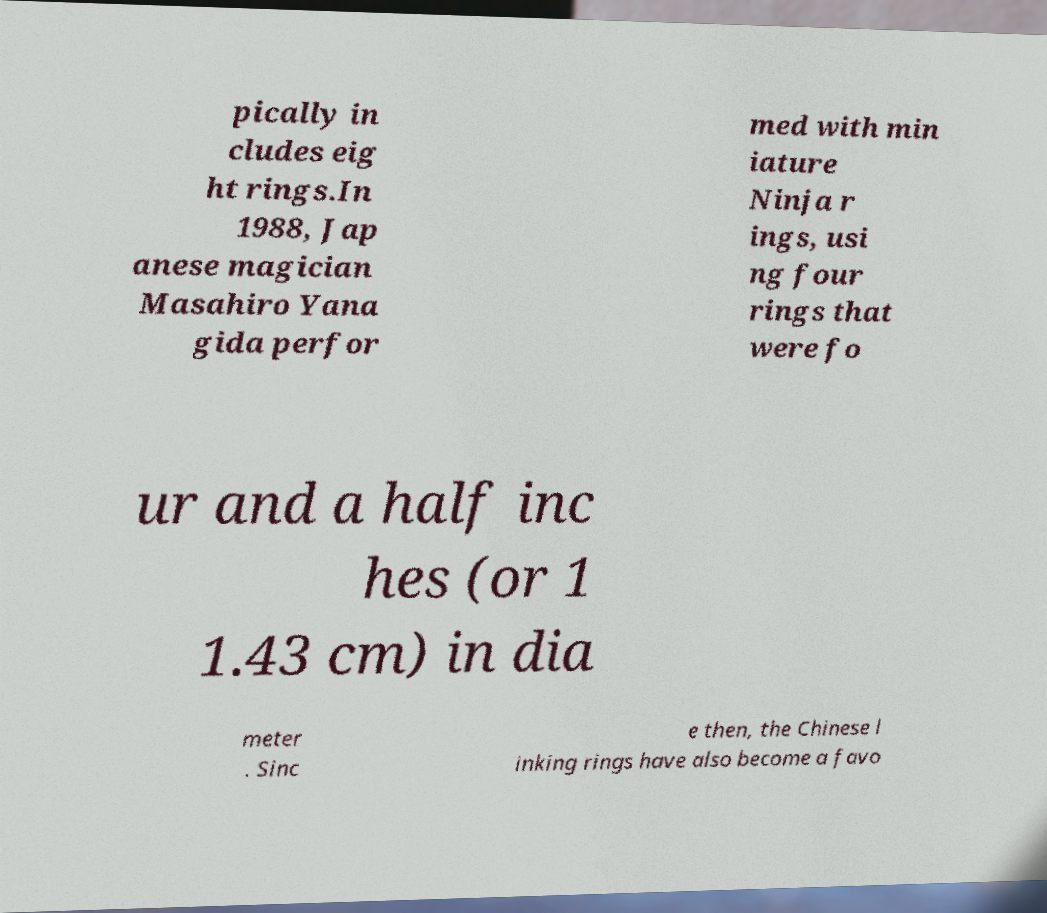Could you extract and type out the text from this image? pically in cludes eig ht rings.In 1988, Jap anese magician Masahiro Yana gida perfor med with min iature Ninja r ings, usi ng four rings that were fo ur and a half inc hes (or 1 1.43 cm) in dia meter . Sinc e then, the Chinese l inking rings have also become a favo 